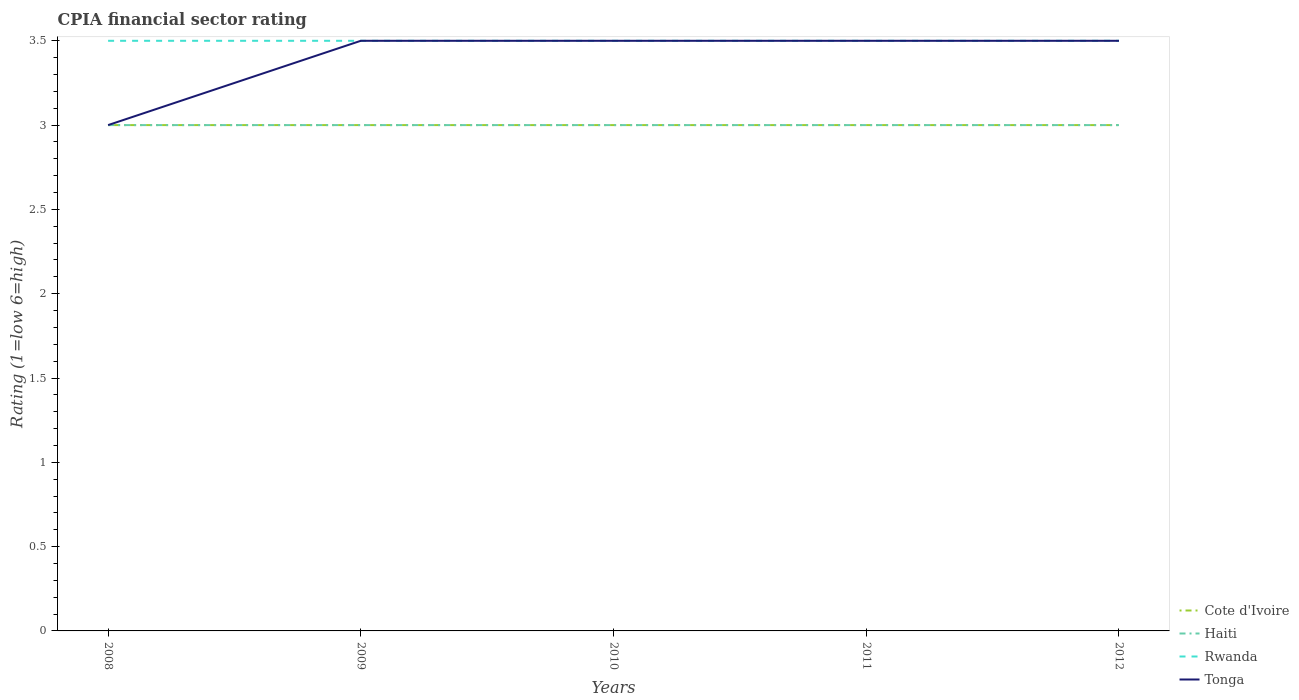Does the line corresponding to Rwanda intersect with the line corresponding to Cote d'Ivoire?
Offer a very short reply. No. Across all years, what is the maximum CPIA rating in Haiti?
Provide a succinct answer. 3. What is the difference between the highest and the second highest CPIA rating in Haiti?
Provide a short and direct response. 0. What is the difference between the highest and the lowest CPIA rating in Rwanda?
Provide a short and direct response. 0. Is the CPIA rating in Cote d'Ivoire strictly greater than the CPIA rating in Haiti over the years?
Provide a short and direct response. No. What is the difference between two consecutive major ticks on the Y-axis?
Provide a succinct answer. 0.5. Are the values on the major ticks of Y-axis written in scientific E-notation?
Your response must be concise. No. Does the graph contain grids?
Provide a short and direct response. No. How many legend labels are there?
Offer a terse response. 4. How are the legend labels stacked?
Provide a short and direct response. Vertical. What is the title of the graph?
Offer a terse response. CPIA financial sector rating. Does "Botswana" appear as one of the legend labels in the graph?
Your response must be concise. No. What is the label or title of the Y-axis?
Make the answer very short. Rating (1=low 6=high). What is the Rating (1=low 6=high) in Cote d'Ivoire in 2008?
Offer a very short reply. 3. What is the Rating (1=low 6=high) in Rwanda in 2008?
Ensure brevity in your answer.  3.5. What is the Rating (1=low 6=high) in Tonga in 2009?
Make the answer very short. 3.5. What is the Rating (1=low 6=high) of Cote d'Ivoire in 2010?
Your response must be concise. 3. What is the Rating (1=low 6=high) of Haiti in 2010?
Provide a succinct answer. 3. What is the Rating (1=low 6=high) in Rwanda in 2010?
Provide a succinct answer. 3.5. What is the Rating (1=low 6=high) of Cote d'Ivoire in 2011?
Keep it short and to the point. 3. What is the Rating (1=low 6=high) in Haiti in 2011?
Offer a terse response. 3. What is the Rating (1=low 6=high) of Tonga in 2012?
Ensure brevity in your answer.  3.5. Across all years, what is the maximum Rating (1=low 6=high) in Haiti?
Give a very brief answer. 3. Across all years, what is the maximum Rating (1=low 6=high) of Rwanda?
Your answer should be compact. 3.5. Across all years, what is the minimum Rating (1=low 6=high) in Tonga?
Provide a succinct answer. 3. What is the total Rating (1=low 6=high) in Haiti in the graph?
Provide a short and direct response. 15. What is the total Rating (1=low 6=high) in Tonga in the graph?
Keep it short and to the point. 17. What is the difference between the Rating (1=low 6=high) of Haiti in 2008 and that in 2009?
Give a very brief answer. 0. What is the difference between the Rating (1=low 6=high) of Cote d'Ivoire in 2008 and that in 2010?
Keep it short and to the point. 0. What is the difference between the Rating (1=low 6=high) in Haiti in 2008 and that in 2010?
Offer a terse response. 0. What is the difference between the Rating (1=low 6=high) of Cote d'Ivoire in 2008 and that in 2012?
Give a very brief answer. 0. What is the difference between the Rating (1=low 6=high) in Rwanda in 2008 and that in 2012?
Make the answer very short. 0. What is the difference between the Rating (1=low 6=high) in Tonga in 2008 and that in 2012?
Your answer should be very brief. -0.5. What is the difference between the Rating (1=low 6=high) of Haiti in 2009 and that in 2010?
Make the answer very short. 0. What is the difference between the Rating (1=low 6=high) in Rwanda in 2009 and that in 2010?
Keep it short and to the point. 0. What is the difference between the Rating (1=low 6=high) of Tonga in 2009 and that in 2010?
Your response must be concise. 0. What is the difference between the Rating (1=low 6=high) of Haiti in 2009 and that in 2011?
Make the answer very short. 0. What is the difference between the Rating (1=low 6=high) in Haiti in 2009 and that in 2012?
Make the answer very short. 0. What is the difference between the Rating (1=low 6=high) in Haiti in 2010 and that in 2011?
Provide a short and direct response. 0. What is the difference between the Rating (1=low 6=high) of Rwanda in 2010 and that in 2011?
Provide a succinct answer. 0. What is the difference between the Rating (1=low 6=high) in Cote d'Ivoire in 2010 and that in 2012?
Provide a short and direct response. 0. What is the difference between the Rating (1=low 6=high) of Tonga in 2010 and that in 2012?
Offer a terse response. 0. What is the difference between the Rating (1=low 6=high) of Cote d'Ivoire in 2011 and that in 2012?
Ensure brevity in your answer.  0. What is the difference between the Rating (1=low 6=high) of Tonga in 2011 and that in 2012?
Provide a succinct answer. 0. What is the difference between the Rating (1=low 6=high) in Cote d'Ivoire in 2008 and the Rating (1=low 6=high) in Tonga in 2010?
Provide a short and direct response. -0.5. What is the difference between the Rating (1=low 6=high) of Haiti in 2008 and the Rating (1=low 6=high) of Rwanda in 2011?
Provide a short and direct response. -0.5. What is the difference between the Rating (1=low 6=high) in Cote d'Ivoire in 2008 and the Rating (1=low 6=high) in Rwanda in 2012?
Your answer should be compact. -0.5. What is the difference between the Rating (1=low 6=high) in Haiti in 2008 and the Rating (1=low 6=high) in Tonga in 2012?
Your answer should be very brief. -0.5. What is the difference between the Rating (1=low 6=high) of Cote d'Ivoire in 2009 and the Rating (1=low 6=high) of Tonga in 2010?
Provide a short and direct response. -0.5. What is the difference between the Rating (1=low 6=high) in Haiti in 2009 and the Rating (1=low 6=high) in Rwanda in 2010?
Keep it short and to the point. -0.5. What is the difference between the Rating (1=low 6=high) of Rwanda in 2009 and the Rating (1=low 6=high) of Tonga in 2010?
Your answer should be very brief. 0. What is the difference between the Rating (1=low 6=high) in Cote d'Ivoire in 2009 and the Rating (1=low 6=high) in Tonga in 2011?
Your response must be concise. -0.5. What is the difference between the Rating (1=low 6=high) in Haiti in 2009 and the Rating (1=low 6=high) in Tonga in 2011?
Your answer should be compact. -0.5. What is the difference between the Rating (1=low 6=high) in Rwanda in 2009 and the Rating (1=low 6=high) in Tonga in 2011?
Offer a very short reply. 0. What is the difference between the Rating (1=low 6=high) in Cote d'Ivoire in 2009 and the Rating (1=low 6=high) in Haiti in 2012?
Make the answer very short. 0. What is the difference between the Rating (1=low 6=high) in Rwanda in 2009 and the Rating (1=low 6=high) in Tonga in 2012?
Your response must be concise. 0. What is the difference between the Rating (1=low 6=high) of Cote d'Ivoire in 2010 and the Rating (1=low 6=high) of Rwanda in 2011?
Provide a succinct answer. -0.5. What is the difference between the Rating (1=low 6=high) of Haiti in 2010 and the Rating (1=low 6=high) of Rwanda in 2011?
Your response must be concise. -0.5. What is the difference between the Rating (1=low 6=high) of Haiti in 2010 and the Rating (1=low 6=high) of Tonga in 2011?
Give a very brief answer. -0.5. What is the difference between the Rating (1=low 6=high) in Cote d'Ivoire in 2010 and the Rating (1=low 6=high) in Rwanda in 2012?
Offer a very short reply. -0.5. What is the difference between the Rating (1=low 6=high) in Cote d'Ivoire in 2011 and the Rating (1=low 6=high) in Haiti in 2012?
Make the answer very short. 0. What is the average Rating (1=low 6=high) of Tonga per year?
Provide a short and direct response. 3.4. In the year 2008, what is the difference between the Rating (1=low 6=high) in Cote d'Ivoire and Rating (1=low 6=high) in Haiti?
Ensure brevity in your answer.  0. In the year 2008, what is the difference between the Rating (1=low 6=high) of Cote d'Ivoire and Rating (1=low 6=high) of Tonga?
Give a very brief answer. 0. In the year 2008, what is the difference between the Rating (1=low 6=high) in Rwanda and Rating (1=low 6=high) in Tonga?
Your answer should be compact. 0.5. In the year 2009, what is the difference between the Rating (1=low 6=high) in Cote d'Ivoire and Rating (1=low 6=high) in Haiti?
Provide a short and direct response. 0. In the year 2009, what is the difference between the Rating (1=low 6=high) of Cote d'Ivoire and Rating (1=low 6=high) of Rwanda?
Your answer should be compact. -0.5. In the year 2009, what is the difference between the Rating (1=low 6=high) of Cote d'Ivoire and Rating (1=low 6=high) of Tonga?
Your answer should be very brief. -0.5. In the year 2009, what is the difference between the Rating (1=low 6=high) in Haiti and Rating (1=low 6=high) in Tonga?
Keep it short and to the point. -0.5. In the year 2009, what is the difference between the Rating (1=low 6=high) in Rwanda and Rating (1=low 6=high) in Tonga?
Your response must be concise. 0. In the year 2010, what is the difference between the Rating (1=low 6=high) in Cote d'Ivoire and Rating (1=low 6=high) in Tonga?
Your answer should be compact. -0.5. In the year 2010, what is the difference between the Rating (1=low 6=high) of Haiti and Rating (1=low 6=high) of Rwanda?
Provide a short and direct response. -0.5. In the year 2010, what is the difference between the Rating (1=low 6=high) of Rwanda and Rating (1=low 6=high) of Tonga?
Offer a very short reply. 0. In the year 2011, what is the difference between the Rating (1=low 6=high) in Haiti and Rating (1=low 6=high) in Rwanda?
Your response must be concise. -0.5. In the year 2012, what is the difference between the Rating (1=low 6=high) in Cote d'Ivoire and Rating (1=low 6=high) in Haiti?
Your answer should be compact. 0. In the year 2012, what is the difference between the Rating (1=low 6=high) in Rwanda and Rating (1=low 6=high) in Tonga?
Provide a short and direct response. 0. What is the ratio of the Rating (1=low 6=high) in Tonga in 2008 to that in 2009?
Your answer should be compact. 0.86. What is the ratio of the Rating (1=low 6=high) of Cote d'Ivoire in 2008 to that in 2010?
Offer a very short reply. 1. What is the ratio of the Rating (1=low 6=high) in Haiti in 2008 to that in 2010?
Offer a terse response. 1. What is the ratio of the Rating (1=low 6=high) of Rwanda in 2008 to that in 2010?
Offer a very short reply. 1. What is the ratio of the Rating (1=low 6=high) of Cote d'Ivoire in 2008 to that in 2011?
Offer a terse response. 1. What is the ratio of the Rating (1=low 6=high) in Tonga in 2008 to that in 2011?
Your answer should be very brief. 0.86. What is the ratio of the Rating (1=low 6=high) of Cote d'Ivoire in 2008 to that in 2012?
Provide a succinct answer. 1. What is the ratio of the Rating (1=low 6=high) in Tonga in 2008 to that in 2012?
Provide a short and direct response. 0.86. What is the ratio of the Rating (1=low 6=high) in Cote d'Ivoire in 2009 to that in 2010?
Your answer should be compact. 1. What is the ratio of the Rating (1=low 6=high) in Haiti in 2009 to that in 2010?
Your answer should be very brief. 1. What is the ratio of the Rating (1=low 6=high) of Tonga in 2009 to that in 2010?
Your answer should be compact. 1. What is the ratio of the Rating (1=low 6=high) in Cote d'Ivoire in 2009 to that in 2011?
Your response must be concise. 1. What is the ratio of the Rating (1=low 6=high) of Haiti in 2009 to that in 2011?
Make the answer very short. 1. What is the ratio of the Rating (1=low 6=high) of Tonga in 2009 to that in 2011?
Ensure brevity in your answer.  1. What is the ratio of the Rating (1=low 6=high) in Cote d'Ivoire in 2009 to that in 2012?
Provide a succinct answer. 1. What is the ratio of the Rating (1=low 6=high) in Haiti in 2009 to that in 2012?
Give a very brief answer. 1. What is the ratio of the Rating (1=low 6=high) of Tonga in 2009 to that in 2012?
Offer a very short reply. 1. What is the ratio of the Rating (1=low 6=high) of Haiti in 2010 to that in 2011?
Your answer should be very brief. 1. What is the ratio of the Rating (1=low 6=high) of Cote d'Ivoire in 2010 to that in 2012?
Provide a succinct answer. 1. What is the ratio of the Rating (1=low 6=high) in Tonga in 2011 to that in 2012?
Provide a succinct answer. 1. What is the difference between the highest and the second highest Rating (1=low 6=high) of Rwanda?
Your answer should be very brief. 0. What is the difference between the highest and the lowest Rating (1=low 6=high) of Haiti?
Make the answer very short. 0. What is the difference between the highest and the lowest Rating (1=low 6=high) of Rwanda?
Your response must be concise. 0. What is the difference between the highest and the lowest Rating (1=low 6=high) of Tonga?
Offer a terse response. 0.5. 